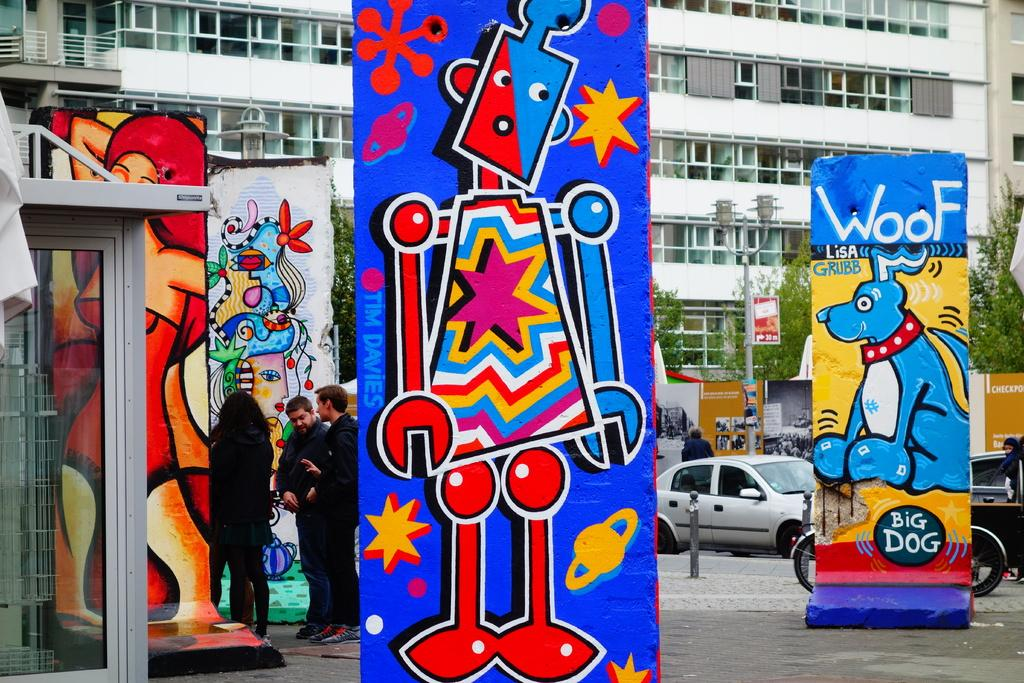Provide a one-sentence caption for the provided image. A large piece of art has the name Lisa Grubb  on it. 